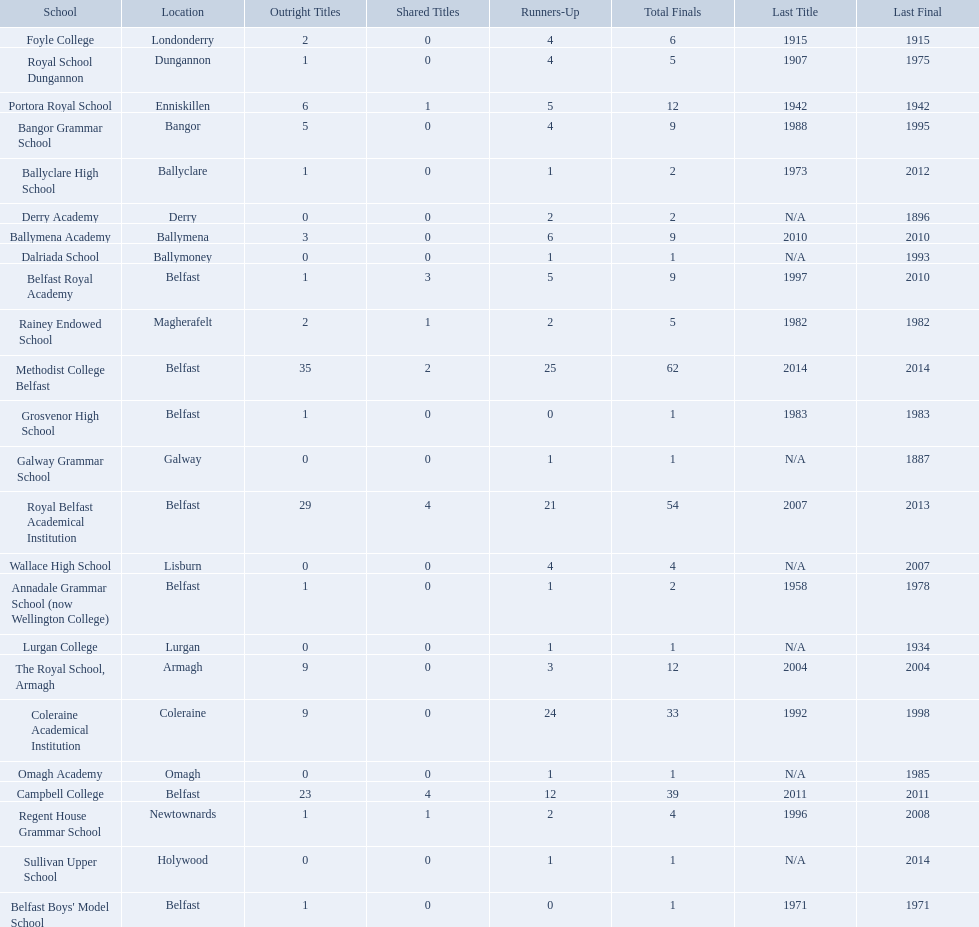Which schools are listed? Methodist College Belfast, Royal Belfast Academical Institution, Campbell College, Coleraine Academical Institution, The Royal School, Armagh, Portora Royal School, Bangor Grammar School, Ballymena Academy, Rainey Endowed School, Foyle College, Belfast Royal Academy, Regent House Grammar School, Royal School Dungannon, Annadale Grammar School (now Wellington College), Ballyclare High School, Belfast Boys' Model School, Grosvenor High School, Wallace High School, Derry Academy, Dalriada School, Galway Grammar School, Lurgan College, Omagh Academy, Sullivan Upper School. When did campbell college win the title last? 2011. When did regent house grammar school win the title last? 1996. Of those two who had the most recent title win? Campbell College. 